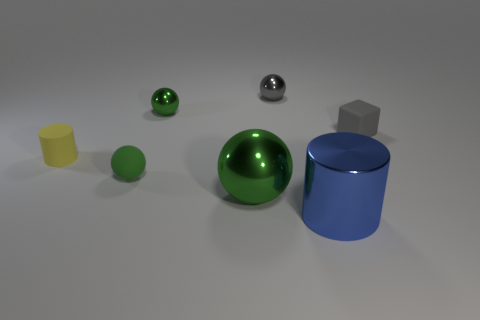Is there anything else that has the same shape as the small gray rubber thing?
Provide a succinct answer. No. What is the color of the metallic ball in front of the yellow object?
Provide a succinct answer. Green. How many other objects are the same color as the small matte cube?
Offer a very short reply. 1. Do the green ball behind the rubber sphere and the shiny cylinder have the same size?
Provide a short and direct response. No. What number of green rubber spheres are behind the large sphere?
Offer a terse response. 1. Is there a metallic object of the same size as the blue shiny cylinder?
Keep it short and to the point. Yes. Do the large metallic ball and the small matte sphere have the same color?
Provide a succinct answer. Yes. What is the color of the metallic ball on the right side of the large shiny thing that is to the left of the blue object?
Offer a terse response. Gray. How many objects are both in front of the small gray cube and right of the tiny green shiny object?
Your response must be concise. 2. How many yellow rubber objects have the same shape as the blue object?
Offer a terse response. 1. 